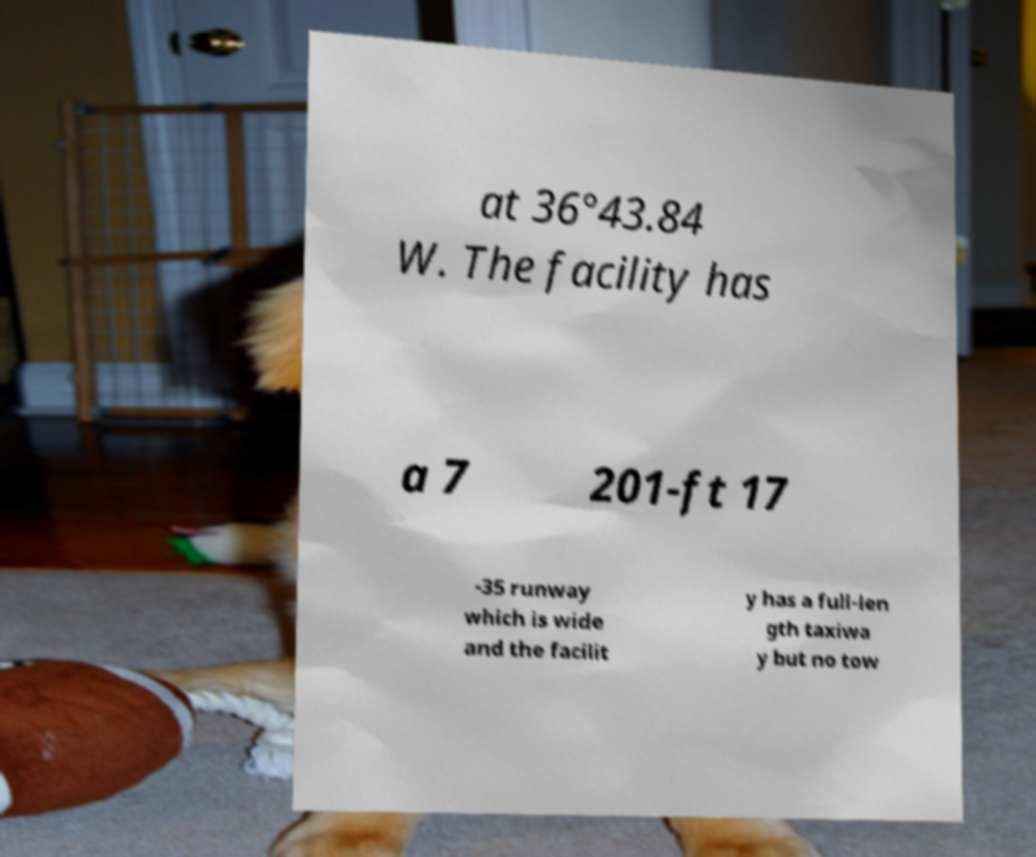Please identify and transcribe the text found in this image. at 36°43.84 W. The facility has a 7 201-ft 17 -35 runway which is wide and the facilit y has a full-len gth taxiwa y but no tow 